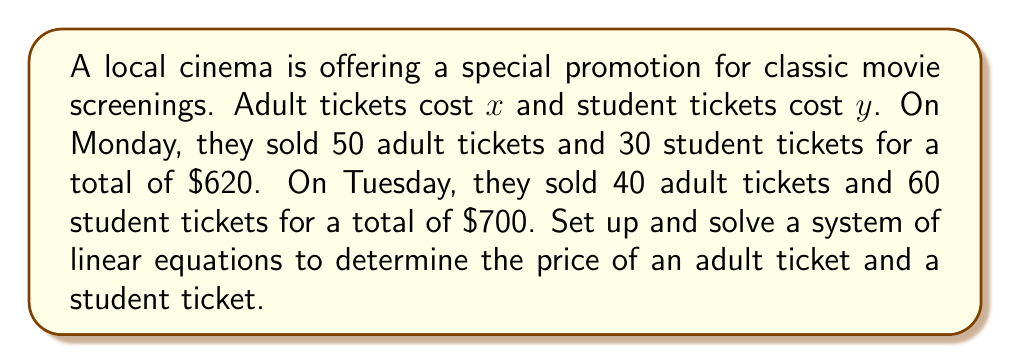Give your solution to this math problem. Let's approach this step-by-step:

1) First, we'll set up our system of equations based on the given information:

   Monday: $50x + 30y = 620$
   Tuesday: $40x + 60y = 700$

2) Now we have a system of two equations with two unknowns:

   $$\begin{cases}
   50x + 30y = 620 \\
   40x + 60y = 700
   \end{cases}$$

3) We can solve this using the elimination method. Let's multiply the first equation by 4 and the second equation by -5:

   $$\begin{cases}
   200x + 120y = 2480 \\
   -200x - 300y = -3500
   \end{cases}$$

4) Now, add these equations:

   $-180y = -1020$

5) Solve for $y$:

   $y = \frac{1020}{180} = \frac{17}{3} \approx 5.67$

6) Substitute this value of $y$ back into one of the original equations. Let's use the first one:

   $50x + 30(\frac{17}{3}) = 620$

7) Simplify:

   $50x + 170 = 620$
   $50x = 450$
   $x = 9$

8) Check: These values satisfy both original equations:

   $50(9) + 30(5.67) \approx 620$
   $40(9) + 60(5.67) \approx 700$

Therefore, an adult ticket costs $9 and a student ticket costs $\frac{17}{3}$ or approximately $5.67.
Answer: Adult ticket: $x = $9
Student ticket: $y = \frac{17}{3} \approx $5.67 